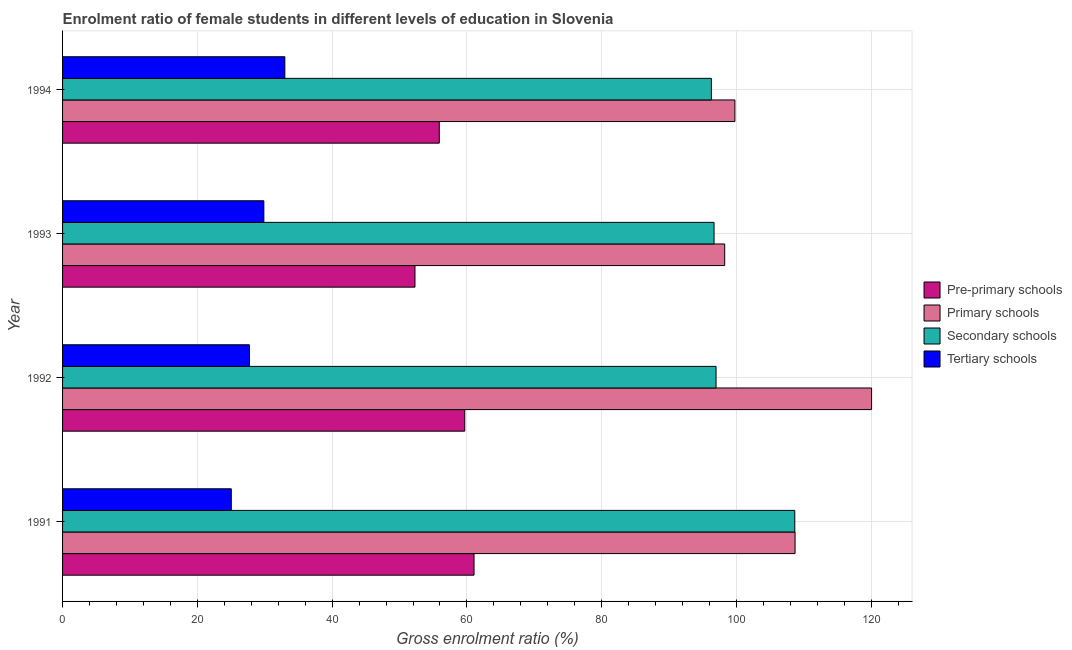Are the number of bars per tick equal to the number of legend labels?
Offer a very short reply. Yes. Are the number of bars on each tick of the Y-axis equal?
Keep it short and to the point. Yes. What is the label of the 2nd group of bars from the top?
Make the answer very short. 1993. In how many cases, is the number of bars for a given year not equal to the number of legend labels?
Provide a short and direct response. 0. What is the gross enrolment ratio(male) in secondary schools in 1994?
Offer a terse response. 96.27. Across all years, what is the maximum gross enrolment ratio(male) in pre-primary schools?
Your answer should be compact. 61.05. Across all years, what is the minimum gross enrolment ratio(male) in tertiary schools?
Ensure brevity in your answer.  25.03. In which year was the gross enrolment ratio(male) in pre-primary schools minimum?
Your answer should be very brief. 1993. What is the total gross enrolment ratio(male) in secondary schools in the graph?
Your answer should be very brief. 398.54. What is the difference between the gross enrolment ratio(male) in pre-primary schools in 1991 and that in 1992?
Provide a short and direct response. 1.38. What is the difference between the gross enrolment ratio(male) in secondary schools in 1994 and the gross enrolment ratio(male) in primary schools in 1993?
Give a very brief answer. -1.98. What is the average gross enrolment ratio(male) in pre-primary schools per year?
Offer a terse response. 57.23. In the year 1991, what is the difference between the gross enrolment ratio(male) in tertiary schools and gross enrolment ratio(male) in pre-primary schools?
Offer a terse response. -36.02. What is the ratio of the gross enrolment ratio(male) in secondary schools in 1991 to that in 1994?
Your response must be concise. 1.13. Is the difference between the gross enrolment ratio(male) in primary schools in 1991 and 1994 greater than the difference between the gross enrolment ratio(male) in secondary schools in 1991 and 1994?
Your response must be concise. No. What is the difference between the highest and the second highest gross enrolment ratio(male) in primary schools?
Ensure brevity in your answer.  11.35. What is the difference between the highest and the lowest gross enrolment ratio(male) in secondary schools?
Offer a terse response. 12.37. In how many years, is the gross enrolment ratio(male) in secondary schools greater than the average gross enrolment ratio(male) in secondary schools taken over all years?
Your answer should be very brief. 1. Is the sum of the gross enrolment ratio(male) in pre-primary schools in 1992 and 1993 greater than the maximum gross enrolment ratio(male) in primary schools across all years?
Your answer should be very brief. No. What does the 4th bar from the top in 1991 represents?
Provide a succinct answer. Pre-primary schools. What does the 2nd bar from the bottom in 1991 represents?
Offer a very short reply. Primary schools. Is it the case that in every year, the sum of the gross enrolment ratio(male) in pre-primary schools and gross enrolment ratio(male) in primary schools is greater than the gross enrolment ratio(male) in secondary schools?
Offer a very short reply. Yes. Are all the bars in the graph horizontal?
Your answer should be compact. Yes. How many years are there in the graph?
Provide a short and direct response. 4. Are the values on the major ticks of X-axis written in scientific E-notation?
Your answer should be compact. No. Does the graph contain any zero values?
Provide a succinct answer. No. Where does the legend appear in the graph?
Your response must be concise. Center right. How many legend labels are there?
Give a very brief answer. 4. How are the legend labels stacked?
Keep it short and to the point. Vertical. What is the title of the graph?
Make the answer very short. Enrolment ratio of female students in different levels of education in Slovenia. What is the label or title of the X-axis?
Your answer should be compact. Gross enrolment ratio (%). What is the label or title of the Y-axis?
Your response must be concise. Year. What is the Gross enrolment ratio (%) in Pre-primary schools in 1991?
Offer a terse response. 61.05. What is the Gross enrolment ratio (%) of Primary schools in 1991?
Make the answer very short. 108.69. What is the Gross enrolment ratio (%) of Secondary schools in 1991?
Keep it short and to the point. 108.64. What is the Gross enrolment ratio (%) in Tertiary schools in 1991?
Your answer should be very brief. 25.03. What is the Gross enrolment ratio (%) in Pre-primary schools in 1992?
Make the answer very short. 59.67. What is the Gross enrolment ratio (%) in Primary schools in 1992?
Your response must be concise. 120.04. What is the Gross enrolment ratio (%) of Secondary schools in 1992?
Provide a succinct answer. 96.96. What is the Gross enrolment ratio (%) of Tertiary schools in 1992?
Ensure brevity in your answer.  27.73. What is the Gross enrolment ratio (%) of Pre-primary schools in 1993?
Ensure brevity in your answer.  52.29. What is the Gross enrolment ratio (%) in Primary schools in 1993?
Your answer should be compact. 98.24. What is the Gross enrolment ratio (%) in Secondary schools in 1993?
Give a very brief answer. 96.67. What is the Gross enrolment ratio (%) of Tertiary schools in 1993?
Ensure brevity in your answer.  29.86. What is the Gross enrolment ratio (%) in Pre-primary schools in 1994?
Make the answer very short. 55.9. What is the Gross enrolment ratio (%) of Primary schools in 1994?
Provide a short and direct response. 99.76. What is the Gross enrolment ratio (%) in Secondary schools in 1994?
Your answer should be compact. 96.27. What is the Gross enrolment ratio (%) of Tertiary schools in 1994?
Provide a short and direct response. 32.98. Across all years, what is the maximum Gross enrolment ratio (%) in Pre-primary schools?
Your answer should be very brief. 61.05. Across all years, what is the maximum Gross enrolment ratio (%) of Primary schools?
Make the answer very short. 120.04. Across all years, what is the maximum Gross enrolment ratio (%) in Secondary schools?
Provide a succinct answer. 108.64. Across all years, what is the maximum Gross enrolment ratio (%) in Tertiary schools?
Your answer should be very brief. 32.98. Across all years, what is the minimum Gross enrolment ratio (%) of Pre-primary schools?
Ensure brevity in your answer.  52.29. Across all years, what is the minimum Gross enrolment ratio (%) in Primary schools?
Make the answer very short. 98.24. Across all years, what is the minimum Gross enrolment ratio (%) in Secondary schools?
Your answer should be compact. 96.27. Across all years, what is the minimum Gross enrolment ratio (%) in Tertiary schools?
Make the answer very short. 25.03. What is the total Gross enrolment ratio (%) in Pre-primary schools in the graph?
Keep it short and to the point. 228.91. What is the total Gross enrolment ratio (%) in Primary schools in the graph?
Keep it short and to the point. 426.73. What is the total Gross enrolment ratio (%) of Secondary schools in the graph?
Provide a succinct answer. 398.54. What is the total Gross enrolment ratio (%) of Tertiary schools in the graph?
Give a very brief answer. 115.61. What is the difference between the Gross enrolment ratio (%) in Pre-primary schools in 1991 and that in 1992?
Offer a terse response. 1.38. What is the difference between the Gross enrolment ratio (%) in Primary schools in 1991 and that in 1992?
Offer a very short reply. -11.35. What is the difference between the Gross enrolment ratio (%) in Secondary schools in 1991 and that in 1992?
Your response must be concise. 11.68. What is the difference between the Gross enrolment ratio (%) of Tertiary schools in 1991 and that in 1992?
Provide a succinct answer. -2.69. What is the difference between the Gross enrolment ratio (%) in Pre-primary schools in 1991 and that in 1993?
Provide a succinct answer. 8.76. What is the difference between the Gross enrolment ratio (%) in Primary schools in 1991 and that in 1993?
Your response must be concise. 10.44. What is the difference between the Gross enrolment ratio (%) in Secondary schools in 1991 and that in 1993?
Offer a very short reply. 11.98. What is the difference between the Gross enrolment ratio (%) in Tertiary schools in 1991 and that in 1993?
Give a very brief answer. -4.83. What is the difference between the Gross enrolment ratio (%) in Pre-primary schools in 1991 and that in 1994?
Offer a terse response. 5.16. What is the difference between the Gross enrolment ratio (%) in Primary schools in 1991 and that in 1994?
Your answer should be compact. 8.93. What is the difference between the Gross enrolment ratio (%) in Secondary schools in 1991 and that in 1994?
Provide a succinct answer. 12.37. What is the difference between the Gross enrolment ratio (%) of Tertiary schools in 1991 and that in 1994?
Offer a terse response. -7.95. What is the difference between the Gross enrolment ratio (%) of Pre-primary schools in 1992 and that in 1993?
Your response must be concise. 7.38. What is the difference between the Gross enrolment ratio (%) of Primary schools in 1992 and that in 1993?
Give a very brief answer. 21.79. What is the difference between the Gross enrolment ratio (%) in Secondary schools in 1992 and that in 1993?
Your answer should be very brief. 0.3. What is the difference between the Gross enrolment ratio (%) of Tertiary schools in 1992 and that in 1993?
Make the answer very short. -2.14. What is the difference between the Gross enrolment ratio (%) in Pre-primary schools in 1992 and that in 1994?
Offer a terse response. 3.78. What is the difference between the Gross enrolment ratio (%) of Primary schools in 1992 and that in 1994?
Give a very brief answer. 20.28. What is the difference between the Gross enrolment ratio (%) in Secondary schools in 1992 and that in 1994?
Offer a very short reply. 0.69. What is the difference between the Gross enrolment ratio (%) in Tertiary schools in 1992 and that in 1994?
Ensure brevity in your answer.  -5.25. What is the difference between the Gross enrolment ratio (%) in Pre-primary schools in 1993 and that in 1994?
Your answer should be very brief. -3.61. What is the difference between the Gross enrolment ratio (%) of Primary schools in 1993 and that in 1994?
Your answer should be very brief. -1.51. What is the difference between the Gross enrolment ratio (%) in Secondary schools in 1993 and that in 1994?
Your answer should be very brief. 0.4. What is the difference between the Gross enrolment ratio (%) in Tertiary schools in 1993 and that in 1994?
Offer a very short reply. -3.12. What is the difference between the Gross enrolment ratio (%) in Pre-primary schools in 1991 and the Gross enrolment ratio (%) in Primary schools in 1992?
Keep it short and to the point. -58.98. What is the difference between the Gross enrolment ratio (%) in Pre-primary schools in 1991 and the Gross enrolment ratio (%) in Secondary schools in 1992?
Make the answer very short. -35.91. What is the difference between the Gross enrolment ratio (%) of Pre-primary schools in 1991 and the Gross enrolment ratio (%) of Tertiary schools in 1992?
Offer a very short reply. 33.33. What is the difference between the Gross enrolment ratio (%) in Primary schools in 1991 and the Gross enrolment ratio (%) in Secondary schools in 1992?
Ensure brevity in your answer.  11.72. What is the difference between the Gross enrolment ratio (%) of Primary schools in 1991 and the Gross enrolment ratio (%) of Tertiary schools in 1992?
Offer a terse response. 80.96. What is the difference between the Gross enrolment ratio (%) in Secondary schools in 1991 and the Gross enrolment ratio (%) in Tertiary schools in 1992?
Your answer should be compact. 80.92. What is the difference between the Gross enrolment ratio (%) in Pre-primary schools in 1991 and the Gross enrolment ratio (%) in Primary schools in 1993?
Your response must be concise. -37.19. What is the difference between the Gross enrolment ratio (%) in Pre-primary schools in 1991 and the Gross enrolment ratio (%) in Secondary schools in 1993?
Make the answer very short. -35.61. What is the difference between the Gross enrolment ratio (%) of Pre-primary schools in 1991 and the Gross enrolment ratio (%) of Tertiary schools in 1993?
Your answer should be compact. 31.19. What is the difference between the Gross enrolment ratio (%) of Primary schools in 1991 and the Gross enrolment ratio (%) of Secondary schools in 1993?
Your answer should be very brief. 12.02. What is the difference between the Gross enrolment ratio (%) of Primary schools in 1991 and the Gross enrolment ratio (%) of Tertiary schools in 1993?
Make the answer very short. 78.82. What is the difference between the Gross enrolment ratio (%) in Secondary schools in 1991 and the Gross enrolment ratio (%) in Tertiary schools in 1993?
Keep it short and to the point. 78.78. What is the difference between the Gross enrolment ratio (%) of Pre-primary schools in 1991 and the Gross enrolment ratio (%) of Primary schools in 1994?
Ensure brevity in your answer.  -38.71. What is the difference between the Gross enrolment ratio (%) of Pre-primary schools in 1991 and the Gross enrolment ratio (%) of Secondary schools in 1994?
Provide a succinct answer. -35.22. What is the difference between the Gross enrolment ratio (%) in Pre-primary schools in 1991 and the Gross enrolment ratio (%) in Tertiary schools in 1994?
Provide a succinct answer. 28.07. What is the difference between the Gross enrolment ratio (%) of Primary schools in 1991 and the Gross enrolment ratio (%) of Secondary schools in 1994?
Your answer should be very brief. 12.42. What is the difference between the Gross enrolment ratio (%) in Primary schools in 1991 and the Gross enrolment ratio (%) in Tertiary schools in 1994?
Your answer should be very brief. 75.7. What is the difference between the Gross enrolment ratio (%) in Secondary schools in 1991 and the Gross enrolment ratio (%) in Tertiary schools in 1994?
Offer a terse response. 75.66. What is the difference between the Gross enrolment ratio (%) of Pre-primary schools in 1992 and the Gross enrolment ratio (%) of Primary schools in 1993?
Give a very brief answer. -38.57. What is the difference between the Gross enrolment ratio (%) of Pre-primary schools in 1992 and the Gross enrolment ratio (%) of Secondary schools in 1993?
Ensure brevity in your answer.  -36.99. What is the difference between the Gross enrolment ratio (%) of Pre-primary schools in 1992 and the Gross enrolment ratio (%) of Tertiary schools in 1993?
Offer a terse response. 29.81. What is the difference between the Gross enrolment ratio (%) in Primary schools in 1992 and the Gross enrolment ratio (%) in Secondary schools in 1993?
Give a very brief answer. 23.37. What is the difference between the Gross enrolment ratio (%) in Primary schools in 1992 and the Gross enrolment ratio (%) in Tertiary schools in 1993?
Ensure brevity in your answer.  90.17. What is the difference between the Gross enrolment ratio (%) of Secondary schools in 1992 and the Gross enrolment ratio (%) of Tertiary schools in 1993?
Offer a terse response. 67.1. What is the difference between the Gross enrolment ratio (%) of Pre-primary schools in 1992 and the Gross enrolment ratio (%) of Primary schools in 1994?
Keep it short and to the point. -40.08. What is the difference between the Gross enrolment ratio (%) in Pre-primary schools in 1992 and the Gross enrolment ratio (%) in Secondary schools in 1994?
Provide a succinct answer. -36.59. What is the difference between the Gross enrolment ratio (%) of Pre-primary schools in 1992 and the Gross enrolment ratio (%) of Tertiary schools in 1994?
Ensure brevity in your answer.  26.69. What is the difference between the Gross enrolment ratio (%) of Primary schools in 1992 and the Gross enrolment ratio (%) of Secondary schools in 1994?
Offer a terse response. 23.77. What is the difference between the Gross enrolment ratio (%) of Primary schools in 1992 and the Gross enrolment ratio (%) of Tertiary schools in 1994?
Give a very brief answer. 87.06. What is the difference between the Gross enrolment ratio (%) of Secondary schools in 1992 and the Gross enrolment ratio (%) of Tertiary schools in 1994?
Give a very brief answer. 63.98. What is the difference between the Gross enrolment ratio (%) in Pre-primary schools in 1993 and the Gross enrolment ratio (%) in Primary schools in 1994?
Ensure brevity in your answer.  -47.47. What is the difference between the Gross enrolment ratio (%) in Pre-primary schools in 1993 and the Gross enrolment ratio (%) in Secondary schools in 1994?
Your answer should be very brief. -43.98. What is the difference between the Gross enrolment ratio (%) in Pre-primary schools in 1993 and the Gross enrolment ratio (%) in Tertiary schools in 1994?
Keep it short and to the point. 19.31. What is the difference between the Gross enrolment ratio (%) of Primary schools in 1993 and the Gross enrolment ratio (%) of Secondary schools in 1994?
Give a very brief answer. 1.98. What is the difference between the Gross enrolment ratio (%) of Primary schools in 1993 and the Gross enrolment ratio (%) of Tertiary schools in 1994?
Make the answer very short. 65.26. What is the difference between the Gross enrolment ratio (%) of Secondary schools in 1993 and the Gross enrolment ratio (%) of Tertiary schools in 1994?
Ensure brevity in your answer.  63.69. What is the average Gross enrolment ratio (%) of Pre-primary schools per year?
Make the answer very short. 57.23. What is the average Gross enrolment ratio (%) in Primary schools per year?
Offer a very short reply. 106.68. What is the average Gross enrolment ratio (%) of Secondary schools per year?
Your response must be concise. 99.64. What is the average Gross enrolment ratio (%) of Tertiary schools per year?
Give a very brief answer. 28.9. In the year 1991, what is the difference between the Gross enrolment ratio (%) in Pre-primary schools and Gross enrolment ratio (%) in Primary schools?
Your response must be concise. -47.63. In the year 1991, what is the difference between the Gross enrolment ratio (%) of Pre-primary schools and Gross enrolment ratio (%) of Secondary schools?
Give a very brief answer. -47.59. In the year 1991, what is the difference between the Gross enrolment ratio (%) of Pre-primary schools and Gross enrolment ratio (%) of Tertiary schools?
Make the answer very short. 36.02. In the year 1991, what is the difference between the Gross enrolment ratio (%) of Primary schools and Gross enrolment ratio (%) of Secondary schools?
Your response must be concise. 0.04. In the year 1991, what is the difference between the Gross enrolment ratio (%) of Primary schools and Gross enrolment ratio (%) of Tertiary schools?
Your response must be concise. 83.65. In the year 1991, what is the difference between the Gross enrolment ratio (%) in Secondary schools and Gross enrolment ratio (%) in Tertiary schools?
Your answer should be compact. 83.61. In the year 1992, what is the difference between the Gross enrolment ratio (%) of Pre-primary schools and Gross enrolment ratio (%) of Primary schools?
Provide a short and direct response. -60.36. In the year 1992, what is the difference between the Gross enrolment ratio (%) in Pre-primary schools and Gross enrolment ratio (%) in Secondary schools?
Give a very brief answer. -37.29. In the year 1992, what is the difference between the Gross enrolment ratio (%) in Pre-primary schools and Gross enrolment ratio (%) in Tertiary schools?
Your response must be concise. 31.95. In the year 1992, what is the difference between the Gross enrolment ratio (%) in Primary schools and Gross enrolment ratio (%) in Secondary schools?
Provide a succinct answer. 23.07. In the year 1992, what is the difference between the Gross enrolment ratio (%) in Primary schools and Gross enrolment ratio (%) in Tertiary schools?
Ensure brevity in your answer.  92.31. In the year 1992, what is the difference between the Gross enrolment ratio (%) in Secondary schools and Gross enrolment ratio (%) in Tertiary schools?
Give a very brief answer. 69.24. In the year 1993, what is the difference between the Gross enrolment ratio (%) of Pre-primary schools and Gross enrolment ratio (%) of Primary schools?
Offer a terse response. -45.95. In the year 1993, what is the difference between the Gross enrolment ratio (%) of Pre-primary schools and Gross enrolment ratio (%) of Secondary schools?
Offer a terse response. -44.38. In the year 1993, what is the difference between the Gross enrolment ratio (%) of Pre-primary schools and Gross enrolment ratio (%) of Tertiary schools?
Keep it short and to the point. 22.43. In the year 1993, what is the difference between the Gross enrolment ratio (%) in Primary schools and Gross enrolment ratio (%) in Secondary schools?
Offer a very short reply. 1.58. In the year 1993, what is the difference between the Gross enrolment ratio (%) of Primary schools and Gross enrolment ratio (%) of Tertiary schools?
Keep it short and to the point. 68.38. In the year 1993, what is the difference between the Gross enrolment ratio (%) in Secondary schools and Gross enrolment ratio (%) in Tertiary schools?
Offer a terse response. 66.8. In the year 1994, what is the difference between the Gross enrolment ratio (%) in Pre-primary schools and Gross enrolment ratio (%) in Primary schools?
Offer a terse response. -43.86. In the year 1994, what is the difference between the Gross enrolment ratio (%) of Pre-primary schools and Gross enrolment ratio (%) of Secondary schools?
Provide a short and direct response. -40.37. In the year 1994, what is the difference between the Gross enrolment ratio (%) in Pre-primary schools and Gross enrolment ratio (%) in Tertiary schools?
Offer a very short reply. 22.91. In the year 1994, what is the difference between the Gross enrolment ratio (%) of Primary schools and Gross enrolment ratio (%) of Secondary schools?
Your response must be concise. 3.49. In the year 1994, what is the difference between the Gross enrolment ratio (%) of Primary schools and Gross enrolment ratio (%) of Tertiary schools?
Keep it short and to the point. 66.78. In the year 1994, what is the difference between the Gross enrolment ratio (%) in Secondary schools and Gross enrolment ratio (%) in Tertiary schools?
Give a very brief answer. 63.29. What is the ratio of the Gross enrolment ratio (%) in Pre-primary schools in 1991 to that in 1992?
Your answer should be very brief. 1.02. What is the ratio of the Gross enrolment ratio (%) in Primary schools in 1991 to that in 1992?
Give a very brief answer. 0.91. What is the ratio of the Gross enrolment ratio (%) in Secondary schools in 1991 to that in 1992?
Make the answer very short. 1.12. What is the ratio of the Gross enrolment ratio (%) of Tertiary schools in 1991 to that in 1992?
Your answer should be compact. 0.9. What is the ratio of the Gross enrolment ratio (%) of Pre-primary schools in 1991 to that in 1993?
Give a very brief answer. 1.17. What is the ratio of the Gross enrolment ratio (%) in Primary schools in 1991 to that in 1993?
Keep it short and to the point. 1.11. What is the ratio of the Gross enrolment ratio (%) in Secondary schools in 1991 to that in 1993?
Offer a terse response. 1.12. What is the ratio of the Gross enrolment ratio (%) of Tertiary schools in 1991 to that in 1993?
Offer a terse response. 0.84. What is the ratio of the Gross enrolment ratio (%) in Pre-primary schools in 1991 to that in 1994?
Your response must be concise. 1.09. What is the ratio of the Gross enrolment ratio (%) in Primary schools in 1991 to that in 1994?
Provide a succinct answer. 1.09. What is the ratio of the Gross enrolment ratio (%) in Secondary schools in 1991 to that in 1994?
Give a very brief answer. 1.13. What is the ratio of the Gross enrolment ratio (%) of Tertiary schools in 1991 to that in 1994?
Provide a succinct answer. 0.76. What is the ratio of the Gross enrolment ratio (%) in Pre-primary schools in 1992 to that in 1993?
Offer a terse response. 1.14. What is the ratio of the Gross enrolment ratio (%) in Primary schools in 1992 to that in 1993?
Ensure brevity in your answer.  1.22. What is the ratio of the Gross enrolment ratio (%) in Secondary schools in 1992 to that in 1993?
Your response must be concise. 1. What is the ratio of the Gross enrolment ratio (%) in Tertiary schools in 1992 to that in 1993?
Your answer should be compact. 0.93. What is the ratio of the Gross enrolment ratio (%) of Pre-primary schools in 1992 to that in 1994?
Make the answer very short. 1.07. What is the ratio of the Gross enrolment ratio (%) of Primary schools in 1992 to that in 1994?
Offer a very short reply. 1.2. What is the ratio of the Gross enrolment ratio (%) in Secondary schools in 1992 to that in 1994?
Ensure brevity in your answer.  1.01. What is the ratio of the Gross enrolment ratio (%) of Tertiary schools in 1992 to that in 1994?
Make the answer very short. 0.84. What is the ratio of the Gross enrolment ratio (%) of Pre-primary schools in 1993 to that in 1994?
Provide a succinct answer. 0.94. What is the ratio of the Gross enrolment ratio (%) of Primary schools in 1993 to that in 1994?
Your answer should be very brief. 0.98. What is the ratio of the Gross enrolment ratio (%) in Secondary schools in 1993 to that in 1994?
Your answer should be compact. 1. What is the ratio of the Gross enrolment ratio (%) of Tertiary schools in 1993 to that in 1994?
Your response must be concise. 0.91. What is the difference between the highest and the second highest Gross enrolment ratio (%) in Pre-primary schools?
Your answer should be very brief. 1.38. What is the difference between the highest and the second highest Gross enrolment ratio (%) in Primary schools?
Keep it short and to the point. 11.35. What is the difference between the highest and the second highest Gross enrolment ratio (%) in Secondary schools?
Give a very brief answer. 11.68. What is the difference between the highest and the second highest Gross enrolment ratio (%) in Tertiary schools?
Ensure brevity in your answer.  3.12. What is the difference between the highest and the lowest Gross enrolment ratio (%) in Pre-primary schools?
Keep it short and to the point. 8.76. What is the difference between the highest and the lowest Gross enrolment ratio (%) of Primary schools?
Your response must be concise. 21.79. What is the difference between the highest and the lowest Gross enrolment ratio (%) of Secondary schools?
Your answer should be very brief. 12.37. What is the difference between the highest and the lowest Gross enrolment ratio (%) of Tertiary schools?
Ensure brevity in your answer.  7.95. 